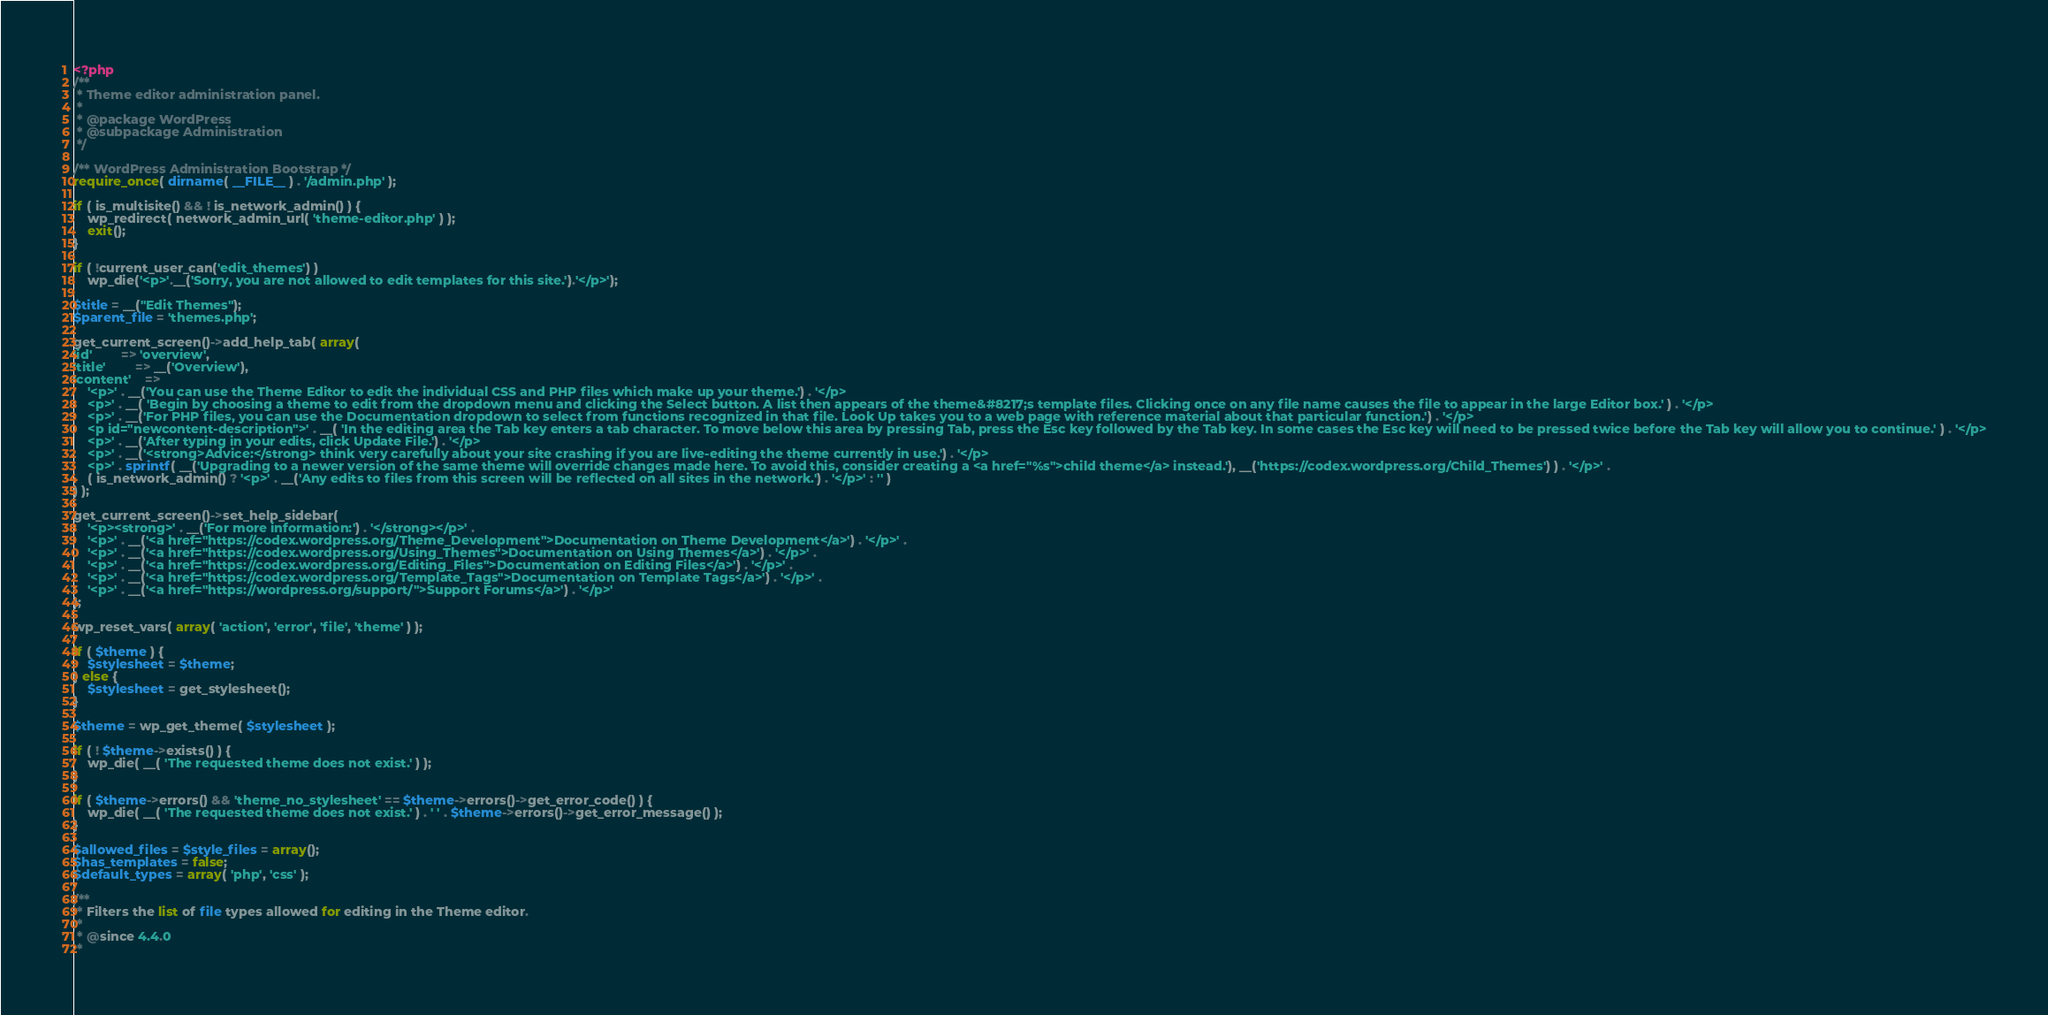Convert code to text. <code><loc_0><loc_0><loc_500><loc_500><_PHP_><?php
/**
 * Theme editor administration panel.
 *
 * @package WordPress
 * @subpackage Administration
 */

/** WordPress Administration Bootstrap */
require_once( dirname( __FILE__ ) . '/admin.php' );

if ( is_multisite() && ! is_network_admin() ) {
	wp_redirect( network_admin_url( 'theme-editor.php' ) );
	exit();
}

if ( !current_user_can('edit_themes') )
	wp_die('<p>'.__('Sorry, you are not allowed to edit templates for this site.').'</p>');

$title = __("Edit Themes");
$parent_file = 'themes.php';

get_current_screen()->add_help_tab( array(
'id'		=> 'overview',
'title'		=> __('Overview'),
'content'	=>
	'<p>' . __('You can use the Theme Editor to edit the individual CSS and PHP files which make up your theme.') . '</p>
	<p>' . __( 'Begin by choosing a theme to edit from the dropdown menu and clicking the Select button. A list then appears of the theme&#8217;s template files. Clicking once on any file name causes the file to appear in the large Editor box.' ) . '</p>
	<p>' . __('For PHP files, you can use the Documentation dropdown to select from functions recognized in that file. Look Up takes you to a web page with reference material about that particular function.') . '</p>
	<p id="newcontent-description">' . __( 'In the editing area the Tab key enters a tab character. To move below this area by pressing Tab, press the Esc key followed by the Tab key. In some cases the Esc key will need to be pressed twice before the Tab key will allow you to continue.' ) . '</p>
	<p>' . __('After typing in your edits, click Update File.') . '</p>
	<p>' . __('<strong>Advice:</strong> think very carefully about your site crashing if you are live-editing the theme currently in use.') . '</p>
	<p>' . sprintf( __('Upgrading to a newer version of the same theme will override changes made here. To avoid this, consider creating a <a href="%s">child theme</a> instead.'), __('https://codex.wordpress.org/Child_Themes') ) . '</p>' .
	( is_network_admin() ? '<p>' . __('Any edits to files from this screen will be reflected on all sites in the network.') . '</p>' : '' )
) );

get_current_screen()->set_help_sidebar(
	'<p><strong>' . __('For more information:') . '</strong></p>' .
	'<p>' . __('<a href="https://codex.wordpress.org/Theme_Development">Documentation on Theme Development</a>') . '</p>' .
	'<p>' . __('<a href="https://codex.wordpress.org/Using_Themes">Documentation on Using Themes</a>') . '</p>' .
	'<p>' . __('<a href="https://codex.wordpress.org/Editing_Files">Documentation on Editing Files</a>') . '</p>' .
	'<p>' . __('<a href="https://codex.wordpress.org/Template_Tags">Documentation on Template Tags</a>') . '</p>' .
	'<p>' . __('<a href="https://wordpress.org/support/">Support Forums</a>') . '</p>'
);

wp_reset_vars( array( 'action', 'error', 'file', 'theme' ) );

if ( $theme ) {
	$stylesheet = $theme;
} else {
	$stylesheet = get_stylesheet();
}

$theme = wp_get_theme( $stylesheet );

if ( ! $theme->exists() ) {
	wp_die( __( 'The requested theme does not exist.' ) );
}

if ( $theme->errors() && 'theme_no_stylesheet' == $theme->errors()->get_error_code() ) {
	wp_die( __( 'The requested theme does not exist.' ) . ' ' . $theme->errors()->get_error_message() );
}

$allowed_files = $style_files = array();
$has_templates = false;
$default_types = array( 'php', 'css' );

/**
 * Filters the list of file types allowed for editing in the Theme editor.
 *
 * @since 4.4.0
 *</code> 